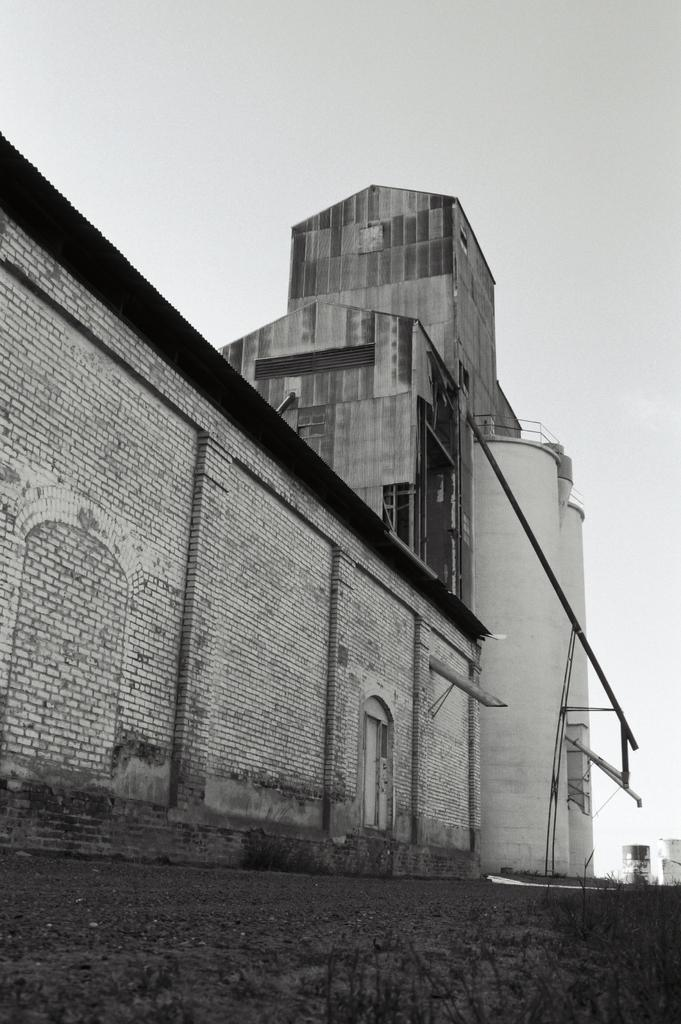What type of structure is present in the image? There is a house and a building in the image. Can you describe the sky in the image? The sky is visible in the image, and it is cloudy. What is the name of the geese flying in the image? There are no geese present in the image, so there is no name to provide. 